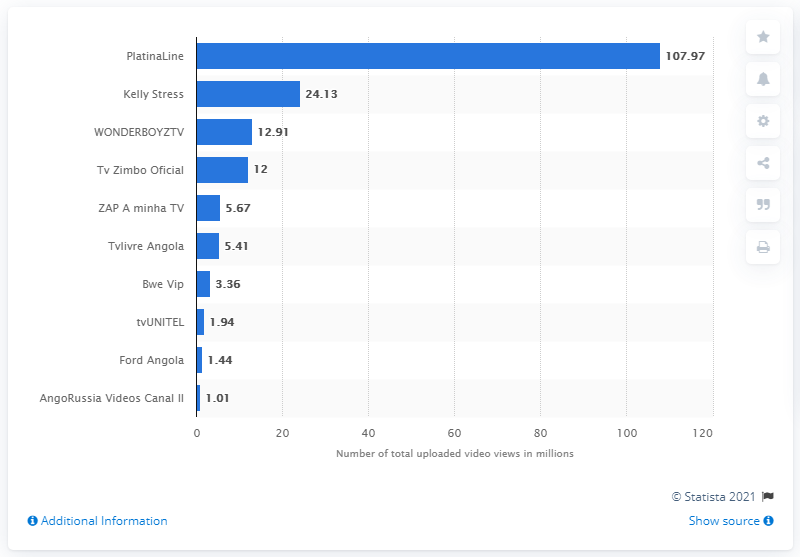Highlight a few significant elements in this photo. PlatinaLine is the most popular YouTube channel in Angola. 